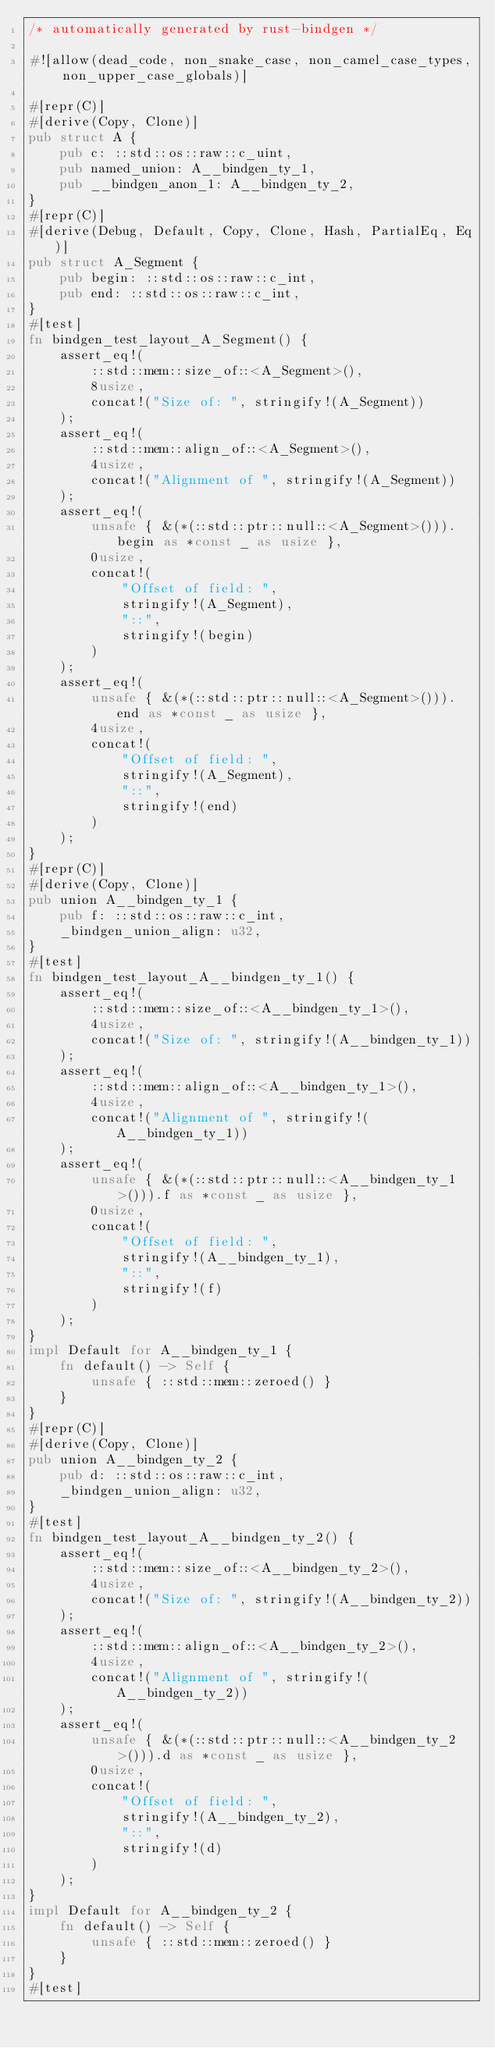Convert code to text. <code><loc_0><loc_0><loc_500><loc_500><_Rust_>/* automatically generated by rust-bindgen */

#![allow(dead_code, non_snake_case, non_camel_case_types, non_upper_case_globals)]

#[repr(C)]
#[derive(Copy, Clone)]
pub struct A {
    pub c: ::std::os::raw::c_uint,
    pub named_union: A__bindgen_ty_1,
    pub __bindgen_anon_1: A__bindgen_ty_2,
}
#[repr(C)]
#[derive(Debug, Default, Copy, Clone, Hash, PartialEq, Eq)]
pub struct A_Segment {
    pub begin: ::std::os::raw::c_int,
    pub end: ::std::os::raw::c_int,
}
#[test]
fn bindgen_test_layout_A_Segment() {
    assert_eq!(
        ::std::mem::size_of::<A_Segment>(),
        8usize,
        concat!("Size of: ", stringify!(A_Segment))
    );
    assert_eq!(
        ::std::mem::align_of::<A_Segment>(),
        4usize,
        concat!("Alignment of ", stringify!(A_Segment))
    );
    assert_eq!(
        unsafe { &(*(::std::ptr::null::<A_Segment>())).begin as *const _ as usize },
        0usize,
        concat!(
            "Offset of field: ",
            stringify!(A_Segment),
            "::",
            stringify!(begin)
        )
    );
    assert_eq!(
        unsafe { &(*(::std::ptr::null::<A_Segment>())).end as *const _ as usize },
        4usize,
        concat!(
            "Offset of field: ",
            stringify!(A_Segment),
            "::",
            stringify!(end)
        )
    );
}
#[repr(C)]
#[derive(Copy, Clone)]
pub union A__bindgen_ty_1 {
    pub f: ::std::os::raw::c_int,
    _bindgen_union_align: u32,
}
#[test]
fn bindgen_test_layout_A__bindgen_ty_1() {
    assert_eq!(
        ::std::mem::size_of::<A__bindgen_ty_1>(),
        4usize,
        concat!("Size of: ", stringify!(A__bindgen_ty_1))
    );
    assert_eq!(
        ::std::mem::align_of::<A__bindgen_ty_1>(),
        4usize,
        concat!("Alignment of ", stringify!(A__bindgen_ty_1))
    );
    assert_eq!(
        unsafe { &(*(::std::ptr::null::<A__bindgen_ty_1>())).f as *const _ as usize },
        0usize,
        concat!(
            "Offset of field: ",
            stringify!(A__bindgen_ty_1),
            "::",
            stringify!(f)
        )
    );
}
impl Default for A__bindgen_ty_1 {
    fn default() -> Self {
        unsafe { ::std::mem::zeroed() }
    }
}
#[repr(C)]
#[derive(Copy, Clone)]
pub union A__bindgen_ty_2 {
    pub d: ::std::os::raw::c_int,
    _bindgen_union_align: u32,
}
#[test]
fn bindgen_test_layout_A__bindgen_ty_2() {
    assert_eq!(
        ::std::mem::size_of::<A__bindgen_ty_2>(),
        4usize,
        concat!("Size of: ", stringify!(A__bindgen_ty_2))
    );
    assert_eq!(
        ::std::mem::align_of::<A__bindgen_ty_2>(),
        4usize,
        concat!("Alignment of ", stringify!(A__bindgen_ty_2))
    );
    assert_eq!(
        unsafe { &(*(::std::ptr::null::<A__bindgen_ty_2>())).d as *const _ as usize },
        0usize,
        concat!(
            "Offset of field: ",
            stringify!(A__bindgen_ty_2),
            "::",
            stringify!(d)
        )
    );
}
impl Default for A__bindgen_ty_2 {
    fn default() -> Self {
        unsafe { ::std::mem::zeroed() }
    }
}
#[test]</code> 